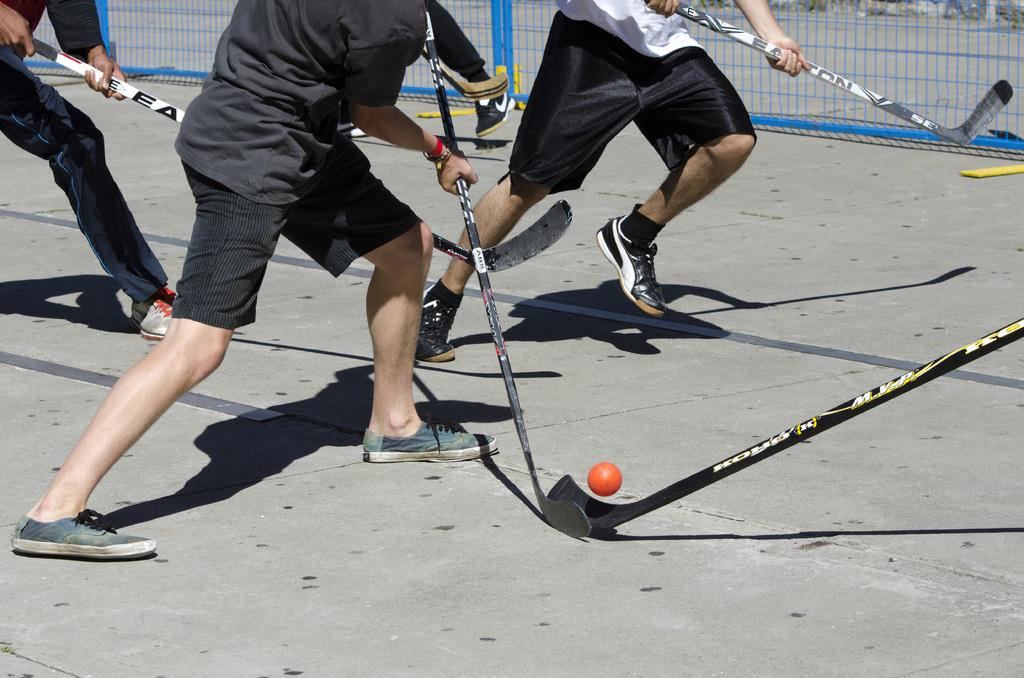How many people are in the image? There are persons in the image. What are the persons holding in the image? The persons are holding sticks. What sport are they playing? They are playing hockey. What object is at the bottom of the image? There is a ball at the bottom of the image. What is at the top of the image? There is a mesh at the top of the image. What news headline is visible on the floor in the image? There is no news headline present in the image, as it is focused on a hockey game. What type of farm animals can be seen grazing in the image? There are no farm animals present in the image; it features a hockey game. 